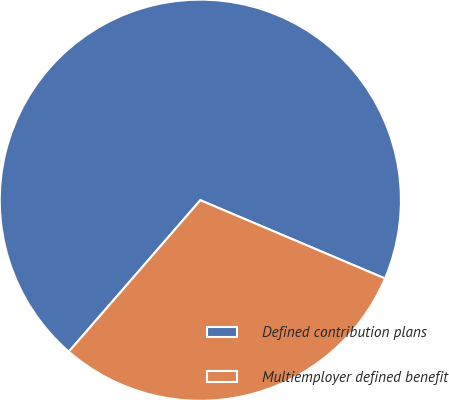Convert chart to OTSL. <chart><loc_0><loc_0><loc_500><loc_500><pie_chart><fcel>Defined contribution plans<fcel>Multiemployer defined benefit<nl><fcel>70.0%<fcel>30.0%<nl></chart> 